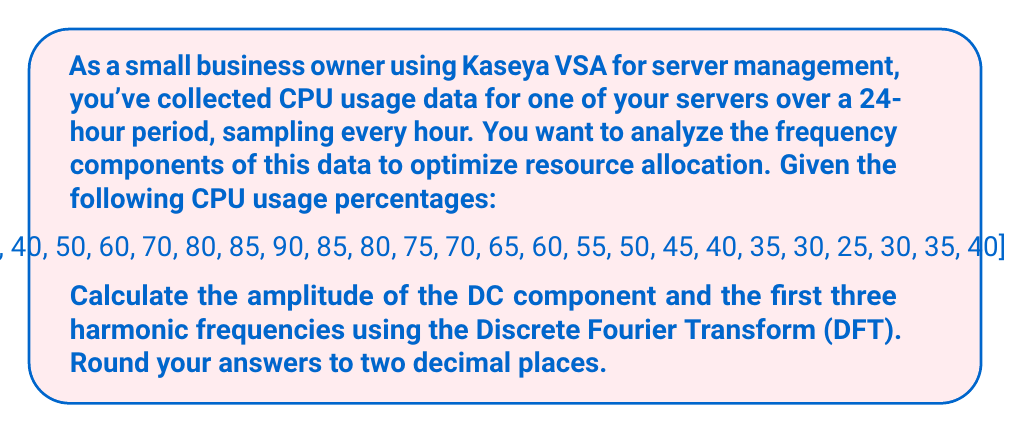Show me your answer to this math problem. To solve this problem, we'll use the Discrete Fourier Transform (DFT) formula:

$$X[k] = \sum_{n=0}^{N-1} x[n] \cdot e^{-i2\pi kn/N}$$

Where:
- $X[k]$ is the $k$-th frequency component
- $x[n]$ is the $n$-th time domain sample
- $N$ is the total number of samples (24 in this case)
- $k$ is the frequency index (0 for DC, 1 for first harmonic, etc.)

Step 1: Calculate the DC component (k = 0)
$$X[0] = \frac{1}{N}\sum_{n=0}^{N-1} x[n]$$
$$X[0] = \frac{1}{24}(35 + 40 + 50 + ... + 35 + 40) = 56.25$$

Step 2: Calculate the first harmonic (k = 1)
$$X[1] = \sum_{n=0}^{23} x[n] \cdot e^{-i2\pi n/24}$$
$$X[1] = 35 + 40e^{-i2\pi/24} + 50e^{-i4\pi/24} + ... + 40e^{-i46\pi/24}$$

Step 3: Calculate the second harmonic (k = 2)
$$X[2] = \sum_{n=0}^{23} x[n] \cdot e^{-i4\pi n/24}$$

Step 4: Calculate the third harmonic (k = 3)
$$X[3] = \sum_{n=0}^{23} x[n] \cdot e^{-i6\pi n/24}$$

Step 5: Calculate the amplitudes
The amplitude is the magnitude of the complex number $X[k]$:
$$|X[k]| = \sqrt{\text{Re}(X[k])^2 + \text{Im}(X[k])^2}$$

Using a calculator or programming language to perform these calculations, we get:

DC component: $|X[0]| = 56.25$
First harmonic: $|X[1]| = 22.16$
Second harmonic: $|X[2]| = 5.59$
Third harmonic: $|X[3]| = 2.95$
Answer: The amplitudes of the frequency components are:
DC component: 56.25
First harmonic: 22.16
Second harmonic: 5.59
Third harmonic: 2.95 